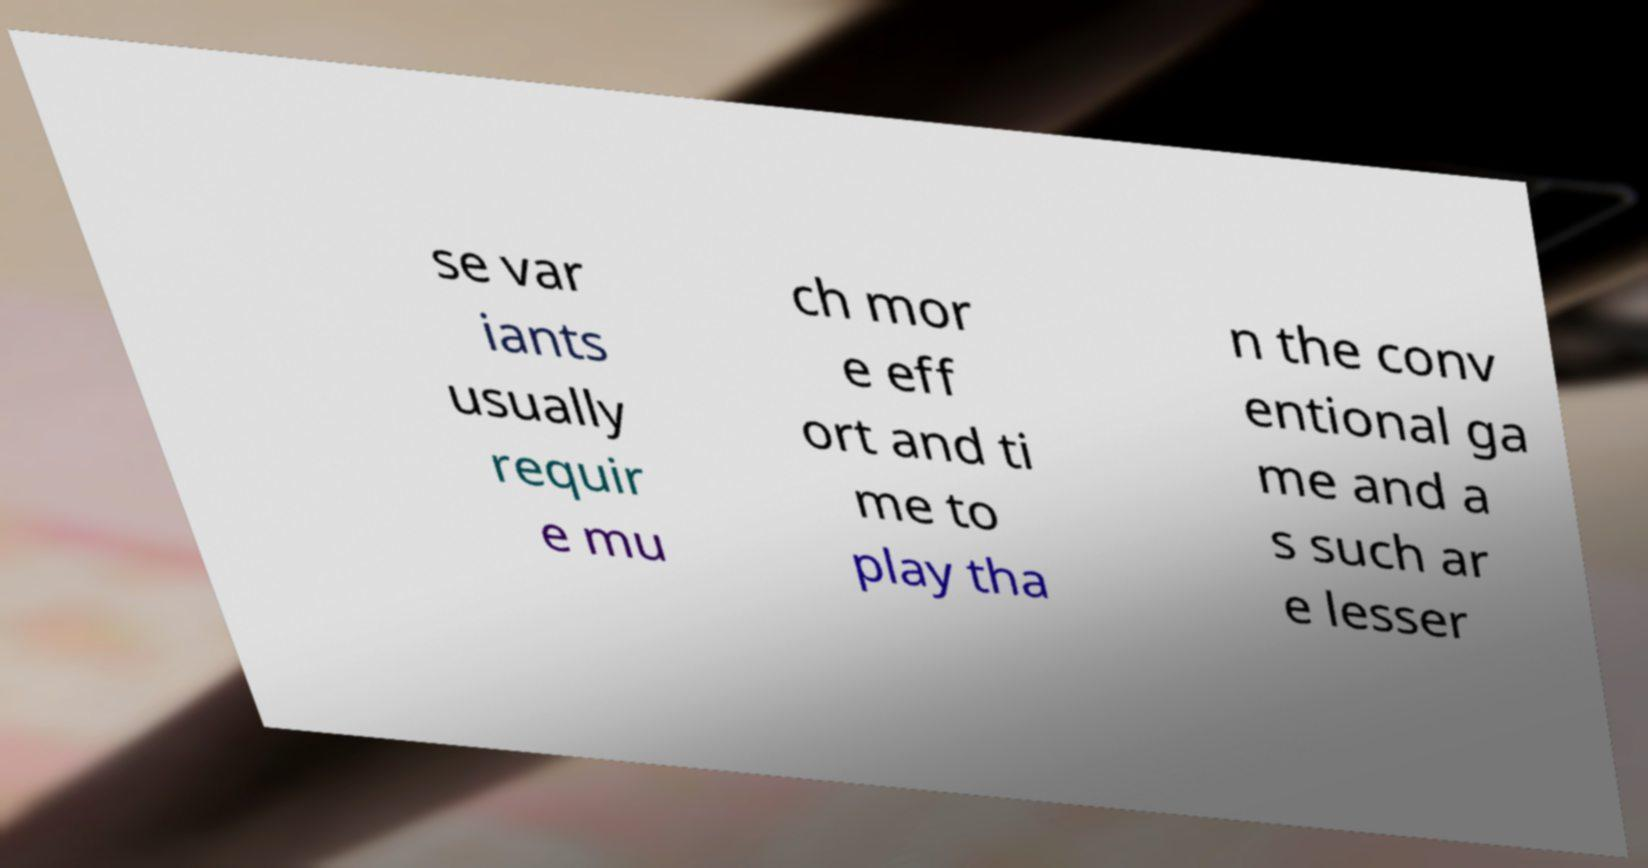Could you extract and type out the text from this image? se var iants usually requir e mu ch mor e eff ort and ti me to play tha n the conv entional ga me and a s such ar e lesser 